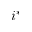<formula> <loc_0><loc_0><loc_500><loc_500>i ^ { * }</formula> 